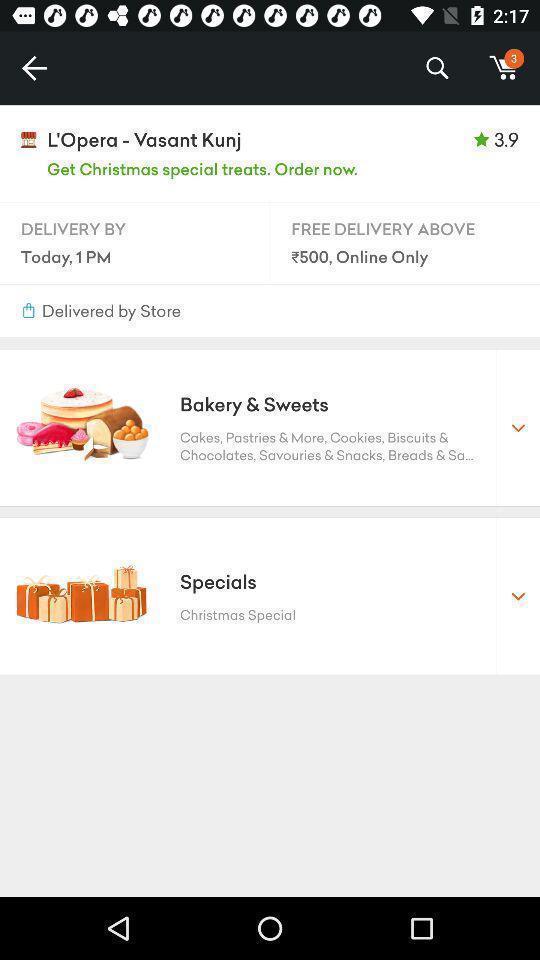What details can you identify in this image? Screen displaying delivery details on shopping app. 